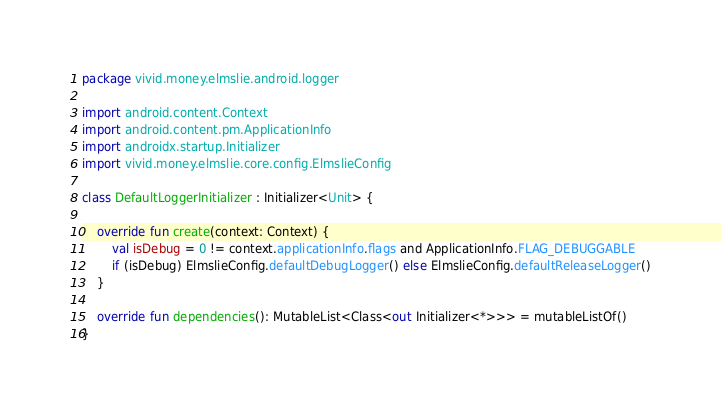<code> <loc_0><loc_0><loc_500><loc_500><_Kotlin_>package vivid.money.elmslie.android.logger

import android.content.Context
import android.content.pm.ApplicationInfo
import androidx.startup.Initializer
import vivid.money.elmslie.core.config.ElmslieConfig

class DefaultLoggerInitializer : Initializer<Unit> {

    override fun create(context: Context) {
        val isDebug = 0 != context.applicationInfo.flags and ApplicationInfo.FLAG_DEBUGGABLE
        if (isDebug) ElmslieConfig.defaultDebugLogger() else ElmslieConfig.defaultReleaseLogger()
    }

    override fun dependencies(): MutableList<Class<out Initializer<*>>> = mutableListOf()
}
</code> 